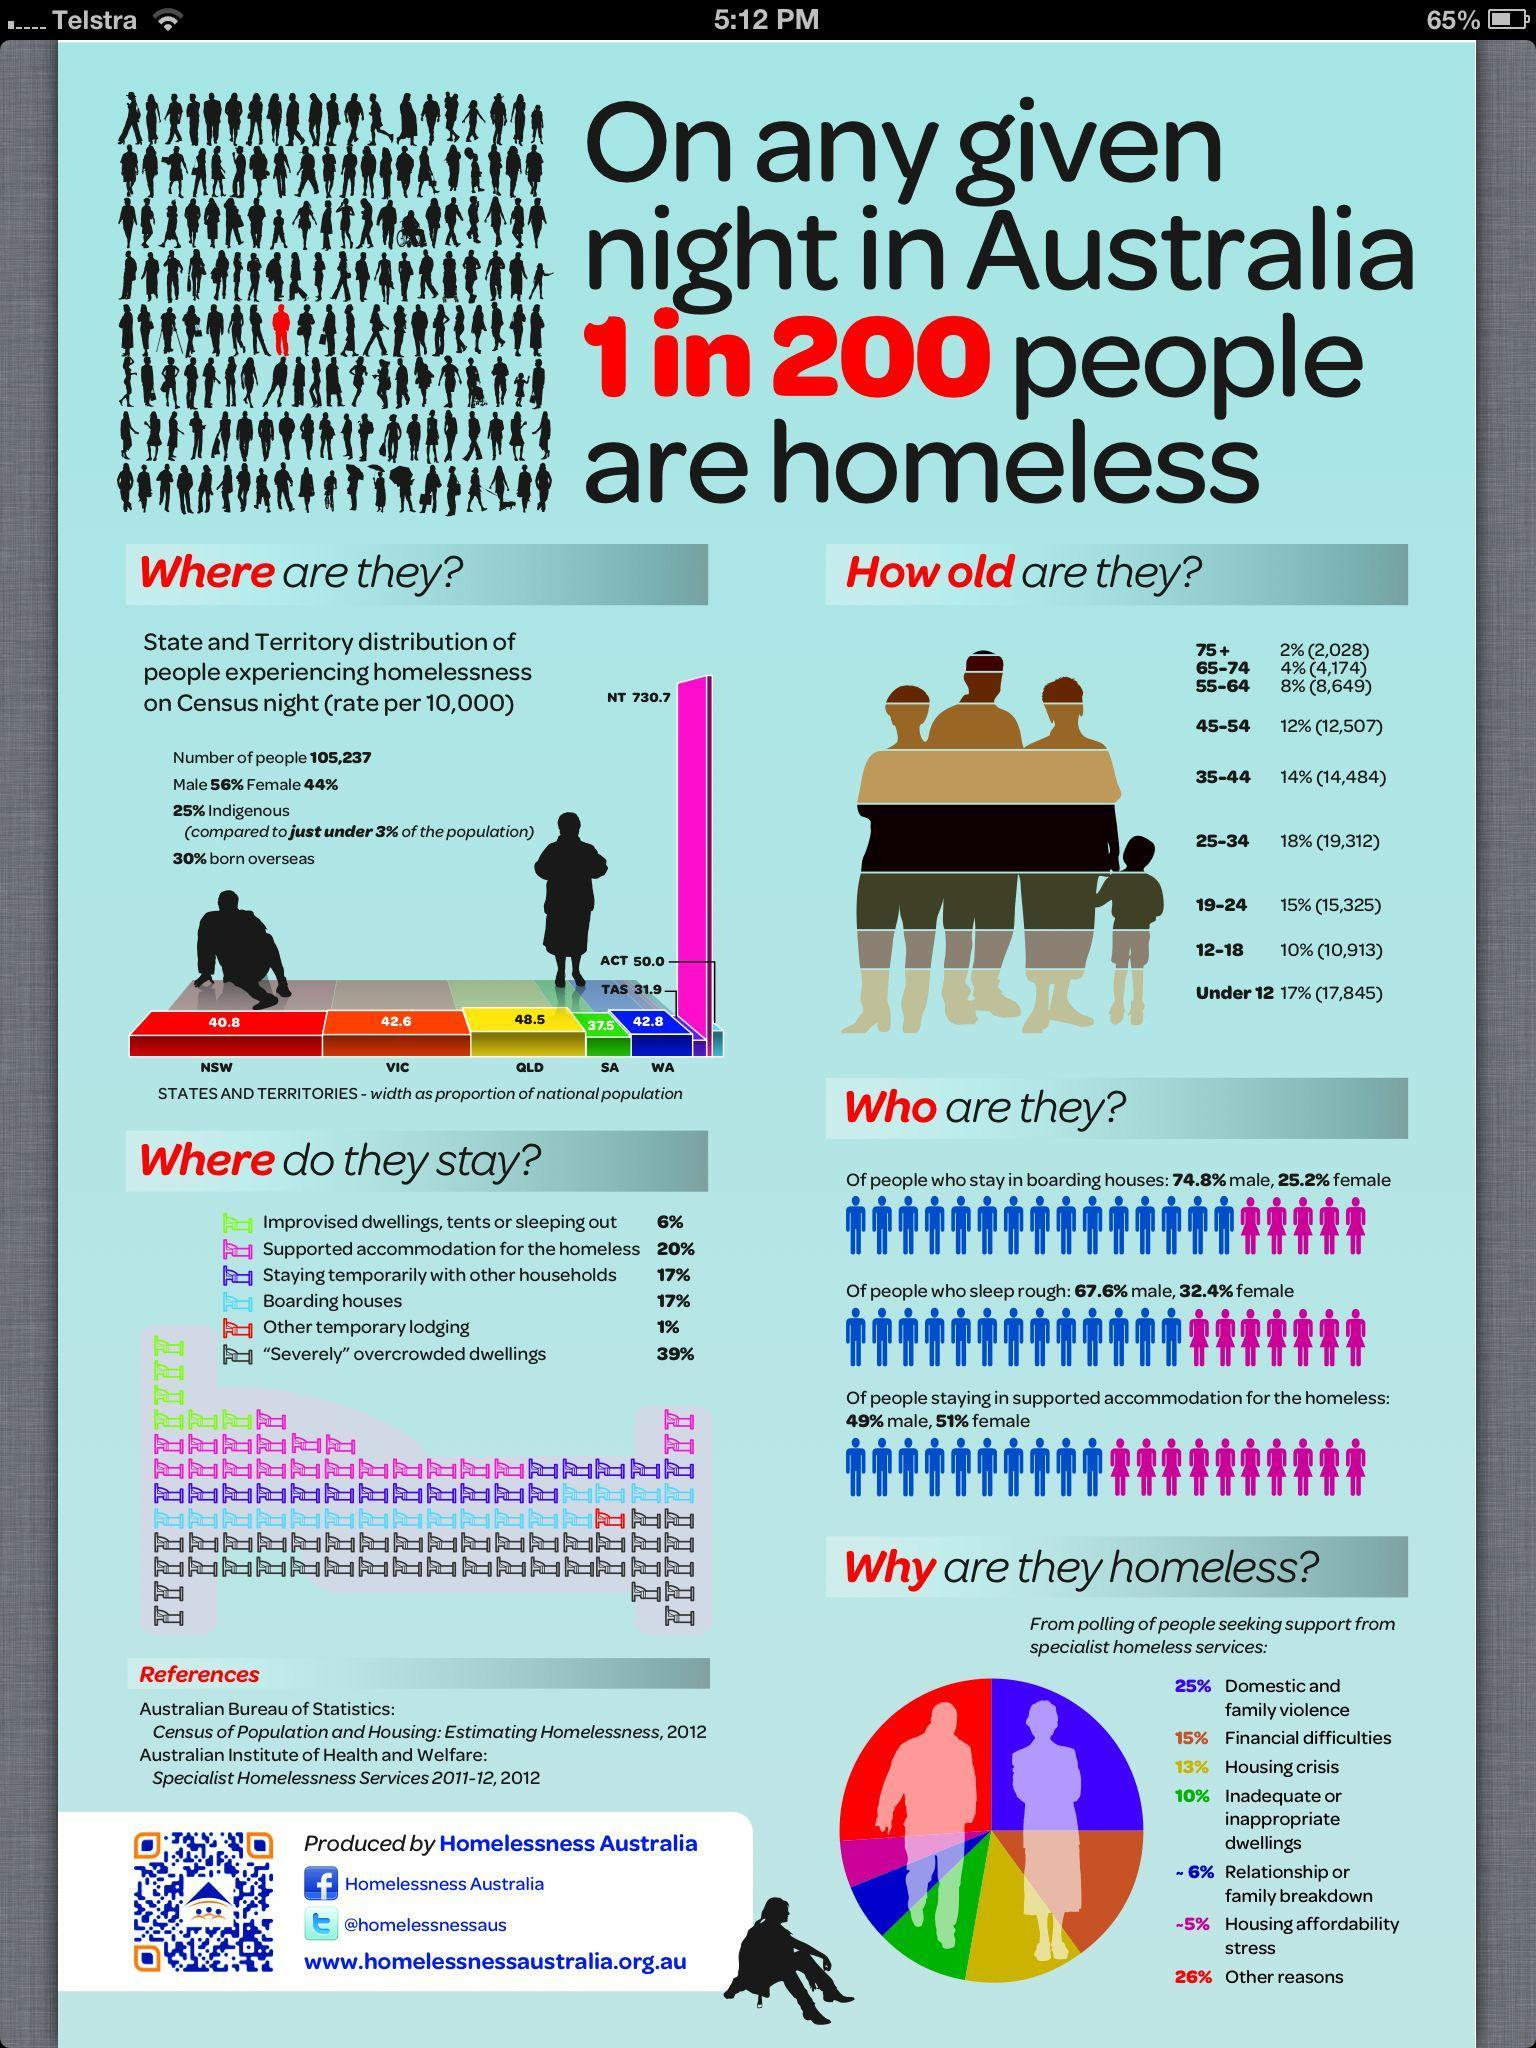Where does one fifth of  the total homeless population stay?
Answer the question with a short phrase. Supported accommodation for the homeless What percentage of the total homeless population stay in boarding houses? 17% The majority of the homeless population is of which gender? Male From the reasons stated for homelessness, which was given by the second lowest percent of people? Relationship or family breakdown What was the reason stated for homelessness by a quarter of the homeless population? Domestic and family violence What is the total percentage of homeless people of ages 55 and above? 14% Majority of the homeless people are of which age group? 25-34 What was the third highest reason given by people for being homeless? Financial difficulties The second highest number of homeless people are of which age group? Under 12 What is the rate (per 10,000) of homeless people in NSW? 40.8 